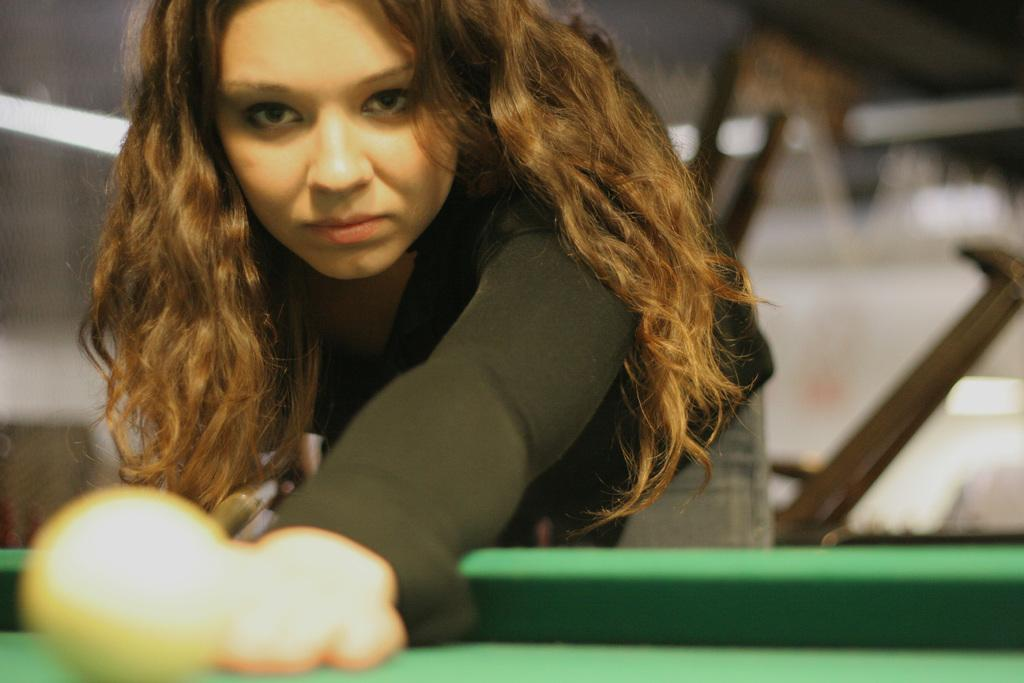Who is the main subject in the image? There is a woman in the image. What is the woman wearing? The woman is wearing a black dress. What activity is the woman engaged in? The woman is playing snooker. Is there a doctor in the image helping the woman play snooker? There is no doctor present in the image, and the woman is playing snooker independently. Can you see any steam coming from the snooker table in the image? There is no steam visible in the image; it is focused on the woman playing snooker. 